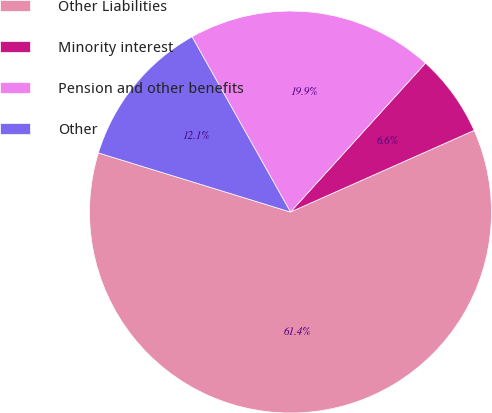<chart> <loc_0><loc_0><loc_500><loc_500><pie_chart><fcel>Other Liabilities<fcel>Minority interest<fcel>Pension and other benefits<fcel>Other<nl><fcel>61.41%<fcel>6.62%<fcel>19.87%<fcel>12.1%<nl></chart> 